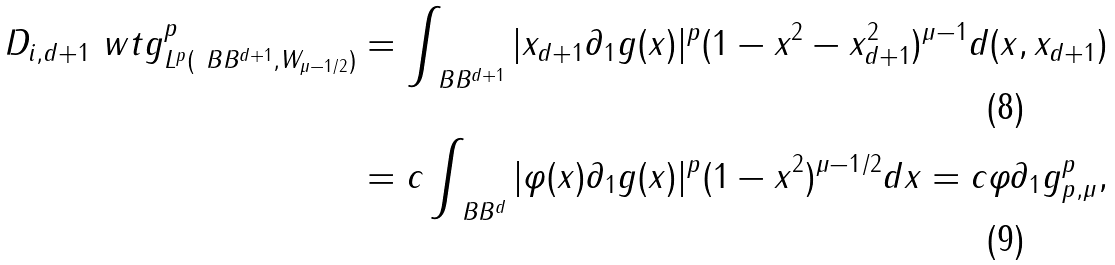<formula> <loc_0><loc_0><loc_500><loc_500>\| D _ { i , d + 1 } \ w t g \| _ { L ^ { p } ( \ B B ^ { d + 1 } , W _ { \mu - 1 / 2 } ) } ^ { p } & = \int _ { \ B B ^ { d + 1 } } | x _ { d + 1 } \partial _ { 1 } g ( x ) | ^ { p } ( 1 - \| x \| ^ { 2 } - x _ { d + 1 } ^ { 2 } ) ^ { \mu - 1 } d ( x , x _ { d + 1 } ) \\ & = c \int _ { \ B B ^ { d } } | \varphi ( x ) \partial _ { 1 } g ( x ) | ^ { p } ( 1 - \| x \| ^ { 2 } ) ^ { \mu - 1 / 2 } d x = c \| \varphi \partial _ { 1 } g \| _ { p , \mu } ^ { p } ,</formula> 